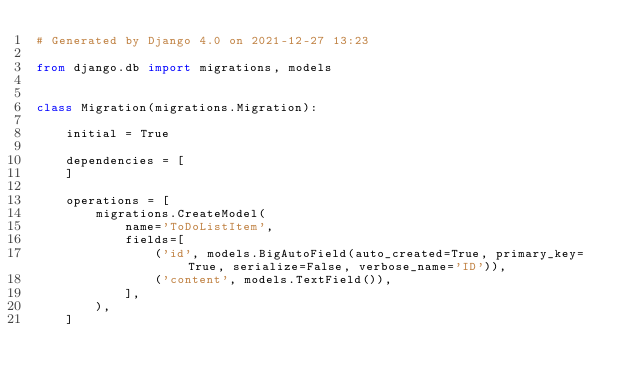<code> <loc_0><loc_0><loc_500><loc_500><_Python_># Generated by Django 4.0 on 2021-12-27 13:23

from django.db import migrations, models


class Migration(migrations.Migration):

    initial = True

    dependencies = [
    ]

    operations = [
        migrations.CreateModel(
            name='ToDoListItem',
            fields=[
                ('id', models.BigAutoField(auto_created=True, primary_key=True, serialize=False, verbose_name='ID')),
                ('content', models.TextField()),
            ],
        ),
    ]
</code> 